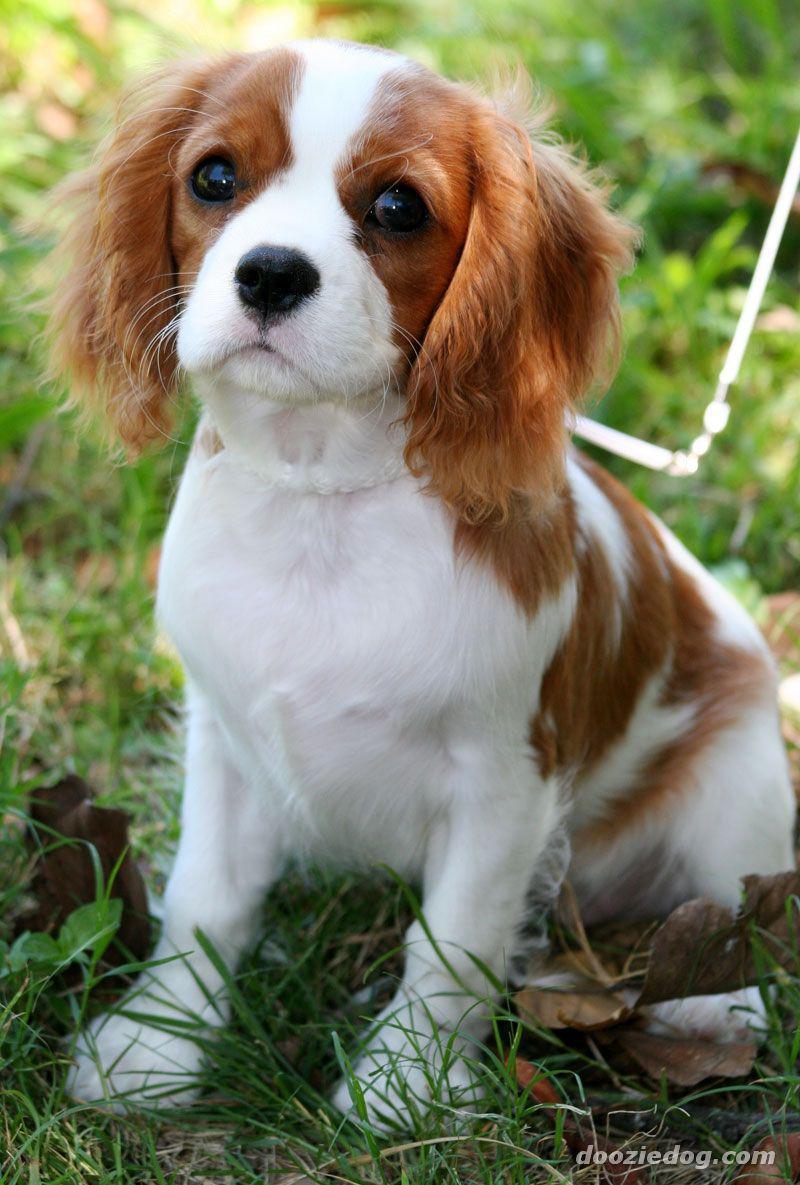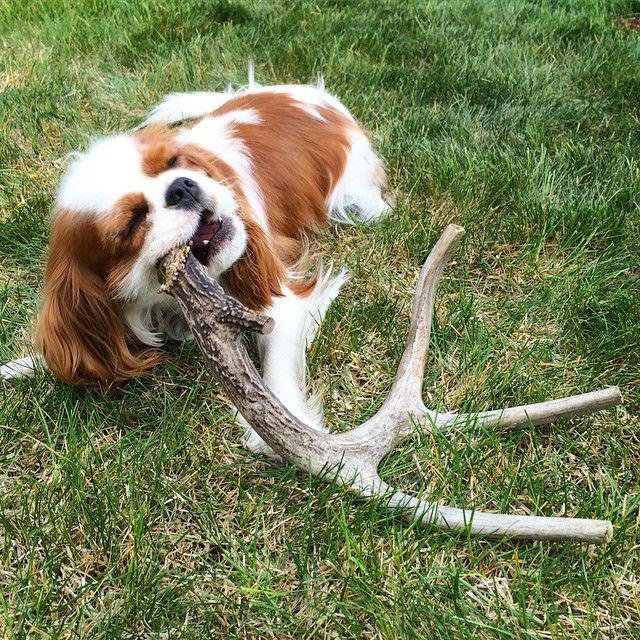The first image is the image on the left, the second image is the image on the right. For the images displayed, is the sentence "Each image shows an orange-and-white spaniel on green grass, and the left image shows a dog sitting upright with body angled leftward." factually correct? Answer yes or no. Yes. The first image is the image on the left, the second image is the image on the right. Evaluate the accuracy of this statement regarding the images: "One dog is laying down.". Is it true? Answer yes or no. Yes. 